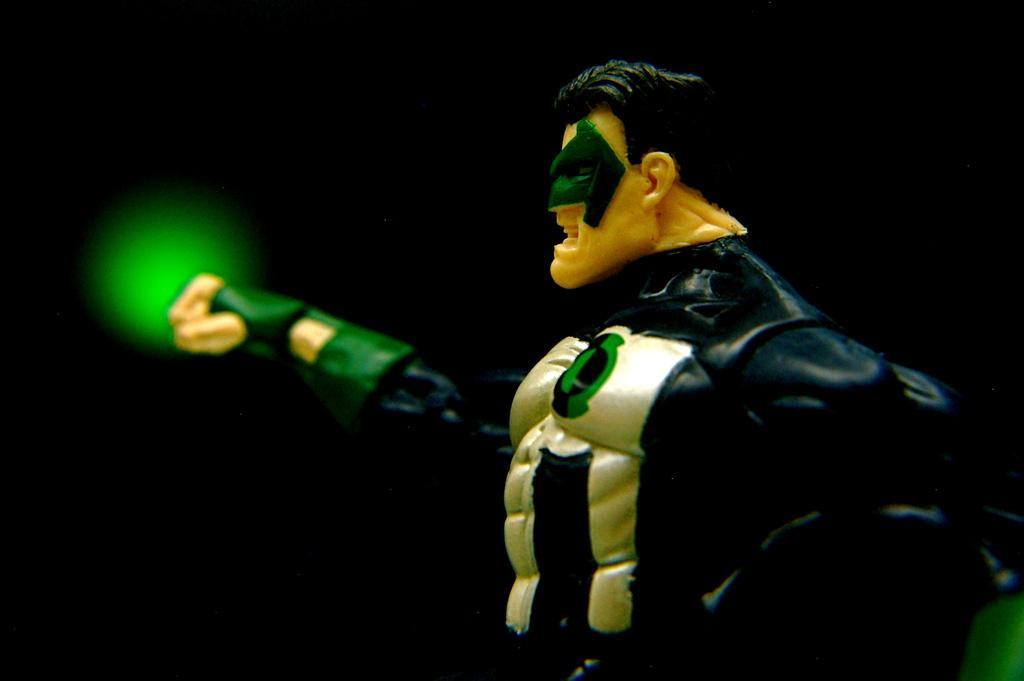Please provide a concise description of this image. Here we can see a cartoon action figure. In the background we can see a green light. 